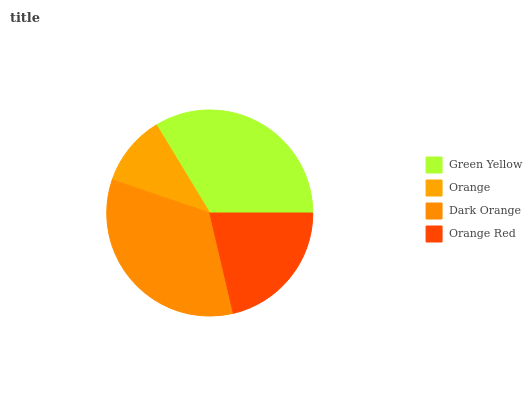Is Orange the minimum?
Answer yes or no. Yes. Is Dark Orange the maximum?
Answer yes or no. Yes. Is Dark Orange the minimum?
Answer yes or no. No. Is Orange the maximum?
Answer yes or no. No. Is Dark Orange greater than Orange?
Answer yes or no. Yes. Is Orange less than Dark Orange?
Answer yes or no. Yes. Is Orange greater than Dark Orange?
Answer yes or no. No. Is Dark Orange less than Orange?
Answer yes or no. No. Is Green Yellow the high median?
Answer yes or no. Yes. Is Orange Red the low median?
Answer yes or no. Yes. Is Orange Red the high median?
Answer yes or no. No. Is Dark Orange the low median?
Answer yes or no. No. 